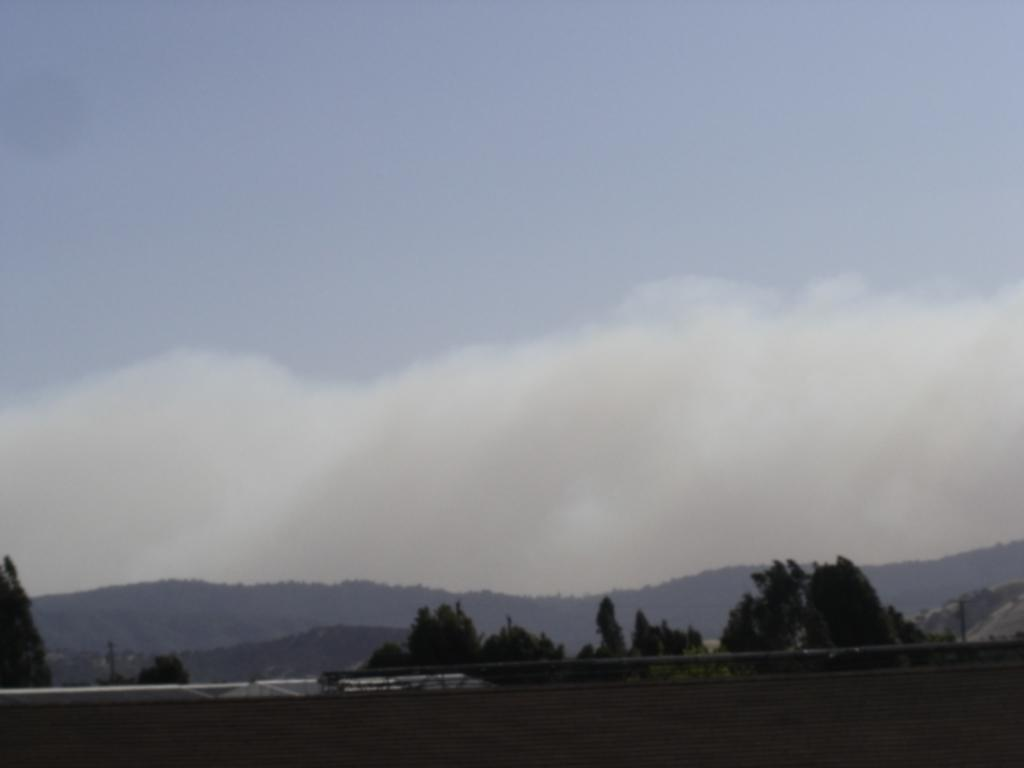What is located at the bottom of the image? There is a wall and a pole at the bottom of the image. What can be seen in the background of the image? There are mountains and trees in the background of the image. What is visible at the top of the image? The sky is visible at the top of the image. How many gold coins are scattered around the pole in the image? There is no mention of gold coins in the image; the pole is the only object mentioned at the bottom of the image. How many boys are climbing the wall in the image? There is no mention of boys or any climbing activity in the image; the wall and pole are the only objects mentioned at the bottom of the image. 